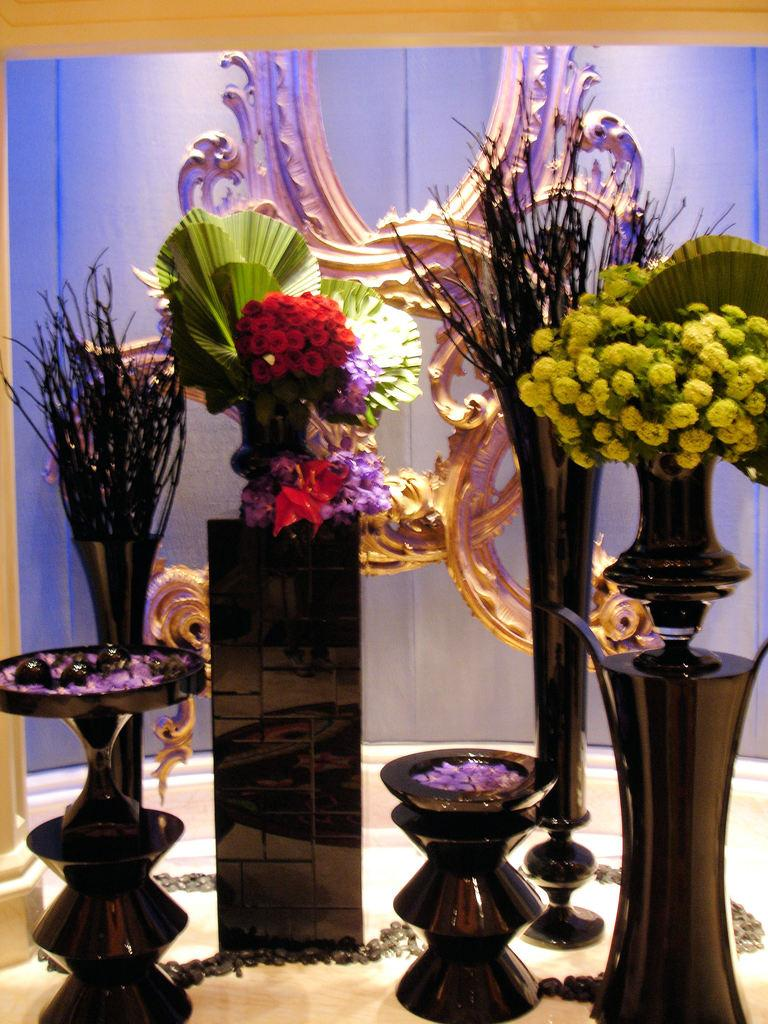What objects are present in the image? There are flower vases in the image. What colors can be seen among the flowers in the vases? Some flowers in the vases are red in color, and some are yellow in color. How many pancakes are stacked on top of each other in the image? There are no pancakes present in the image; it features flower vases with red and yellow flowers. 